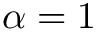<formula> <loc_0><loc_0><loc_500><loc_500>\alpha = 1</formula> 